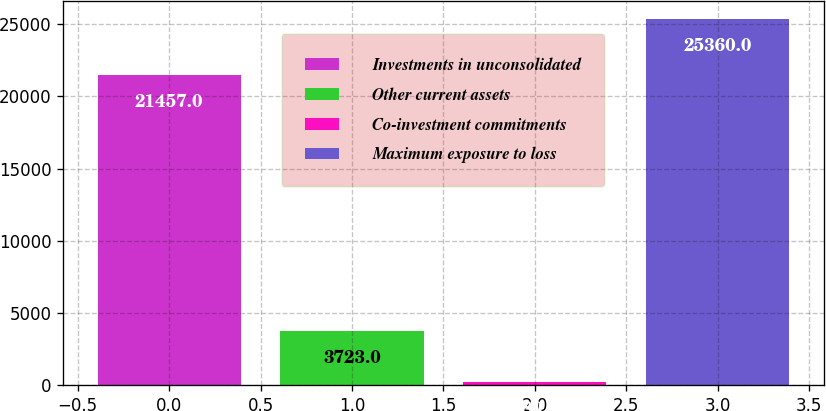Convert chart to OTSL. <chart><loc_0><loc_0><loc_500><loc_500><bar_chart><fcel>Investments in unconsolidated<fcel>Other current assets<fcel>Co-investment commitments<fcel>Maximum exposure to loss<nl><fcel>21457<fcel>3723<fcel>180<fcel>25360<nl></chart> 